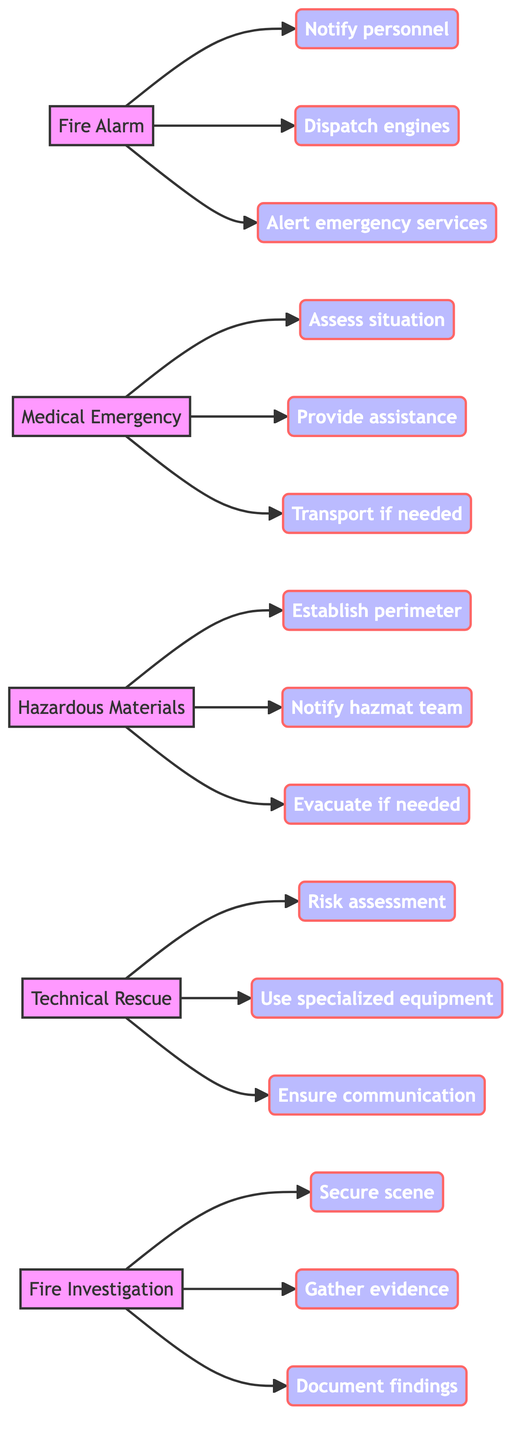What is the first step in the Fire Alarm protocol? The first step under the Fire Alarm protocol is to notify fire station personnel. This can be identified directly from the node where “Notify personnel” is displayed as a step linked to the Fire Alarm node.
Answer: Notify personnel How many nodes are present in the diagram? The diagram contains five main nodes representing different types of emergency calls: Fire Alarm, Medical Emergency, Hazardous Materials, Technical Rescue, and Fire Investigation. Thus, the total count of nodes is five.
Answer: 5 What step follows "Assess the situation" in the Medical Emergency protocol? After "Assess the situation," the next step in the Medical Emergency protocol is "Provide immediate medical assistance." This can be traced by following the directed edge from the "Assess situation" step to the next connected step.
Answer: Provide immediate medical assistance What is required after establishing a safe perimeter in a Hazardous Materials Incident? Following the action of establishing a safe perimeter, the next required step is to notify the hazardous materials team. This is found by following the directed link from the "Establish perimeter" step to the next in sequence.
Answer: Notify hazmat team Which protocol includes a step to "Document findings"? The step to "Document findings" is part of the Fire Investigation protocol. By examining the connections from the Fire Investigation node, it can be determined that this step is explicitly included there.
Answer: Fire Investigation What is the relationship between "Use specialized rescue equipment" and "Risk assessment"? The relationship is that "Use specialized rescue equipment" is a subsequent step that follows the "Risk assessment" step in the Technical Rescue protocol. These steps are connected in a linear manner, indicating that one follows the other.
Answer: Sequential steps What is the last step in the Hazardous Materials protocol? The last step in the Hazardous Materials protocol is "Evacuate nearby areas if needed." This is determined by examining the steps connected to the Hazardous Materials node and identifying which step is the final one.
Answer: Evacuate if needed How many steps are included in the Technical Rescue protocol? The Technical Rescue protocol consists of three steps: "Perform a risk assessment," "Use specialized rescue equipment," and "Ensure communication with other responding teams." This count can be verified by looking at the steps linked to the Technical Rescue node.
Answer: 3 What type of incident requires a thorough investigation post-event? A thorough investigation is necessary after a Fire incident, as indicated by the Fire Investigation node which outlines the steps involved in this process.
Answer: Fire incident 